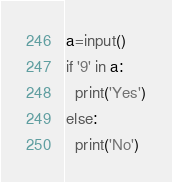<code> <loc_0><loc_0><loc_500><loc_500><_Python_>a=input()
if '9' in a:
  print('Yes')
else:
  print('No')
</code> 